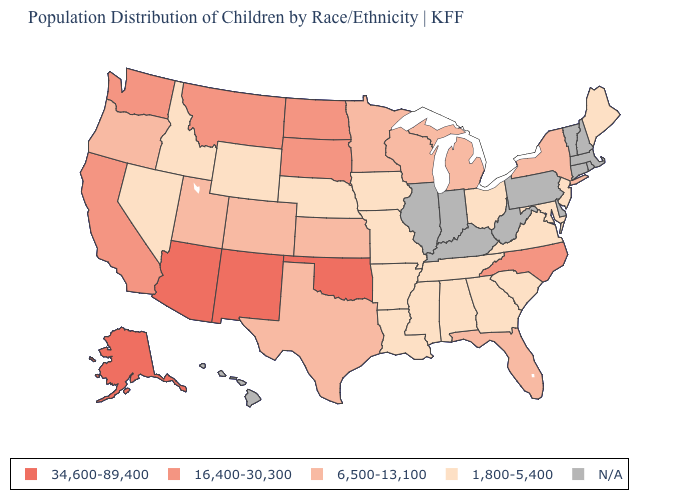Does Kansas have the lowest value in the USA?
Short answer required. No. How many symbols are there in the legend?
Write a very short answer. 5. What is the value of Virginia?
Concise answer only. 1,800-5,400. What is the highest value in the West ?
Write a very short answer. 34,600-89,400. What is the lowest value in states that border North Dakota?
Write a very short answer. 6,500-13,100. Which states have the lowest value in the West?
Quick response, please. Idaho, Nevada, Wyoming. Does Oklahoma have the highest value in the South?
Be succinct. Yes. Name the states that have a value in the range 6,500-13,100?
Concise answer only. Colorado, Florida, Kansas, Michigan, Minnesota, New York, Oregon, Texas, Utah, Wisconsin. Among the states that border Idaho , does Nevada have the lowest value?
Give a very brief answer. Yes. Does Texas have the lowest value in the South?
Write a very short answer. No. What is the highest value in the Northeast ?
Keep it brief. 6,500-13,100. What is the value of Rhode Island?
Write a very short answer. N/A. What is the lowest value in the USA?
Quick response, please. 1,800-5,400. Name the states that have a value in the range 34,600-89,400?
Answer briefly. Alaska, Arizona, New Mexico, Oklahoma. 